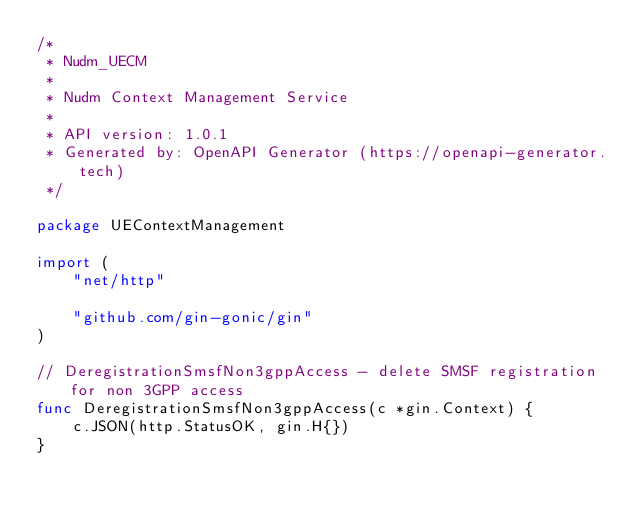Convert code to text. <code><loc_0><loc_0><loc_500><loc_500><_Go_>/*
 * Nudm_UECM
 *
 * Nudm Context Management Service
 *
 * API version: 1.0.1
 * Generated by: OpenAPI Generator (https://openapi-generator.tech)
 */

package UEContextManagement

import (
	"net/http"

	"github.com/gin-gonic/gin"
)

// DeregistrationSmsfNon3gppAccess - delete SMSF registration for non 3GPP access
func DeregistrationSmsfNon3gppAccess(c *gin.Context) {
	c.JSON(http.StatusOK, gin.H{})
}
</code> 